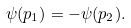Convert formula to latex. <formula><loc_0><loc_0><loc_500><loc_500>\psi ( p _ { 1 } ) = - \psi ( p _ { 2 } ) .</formula> 